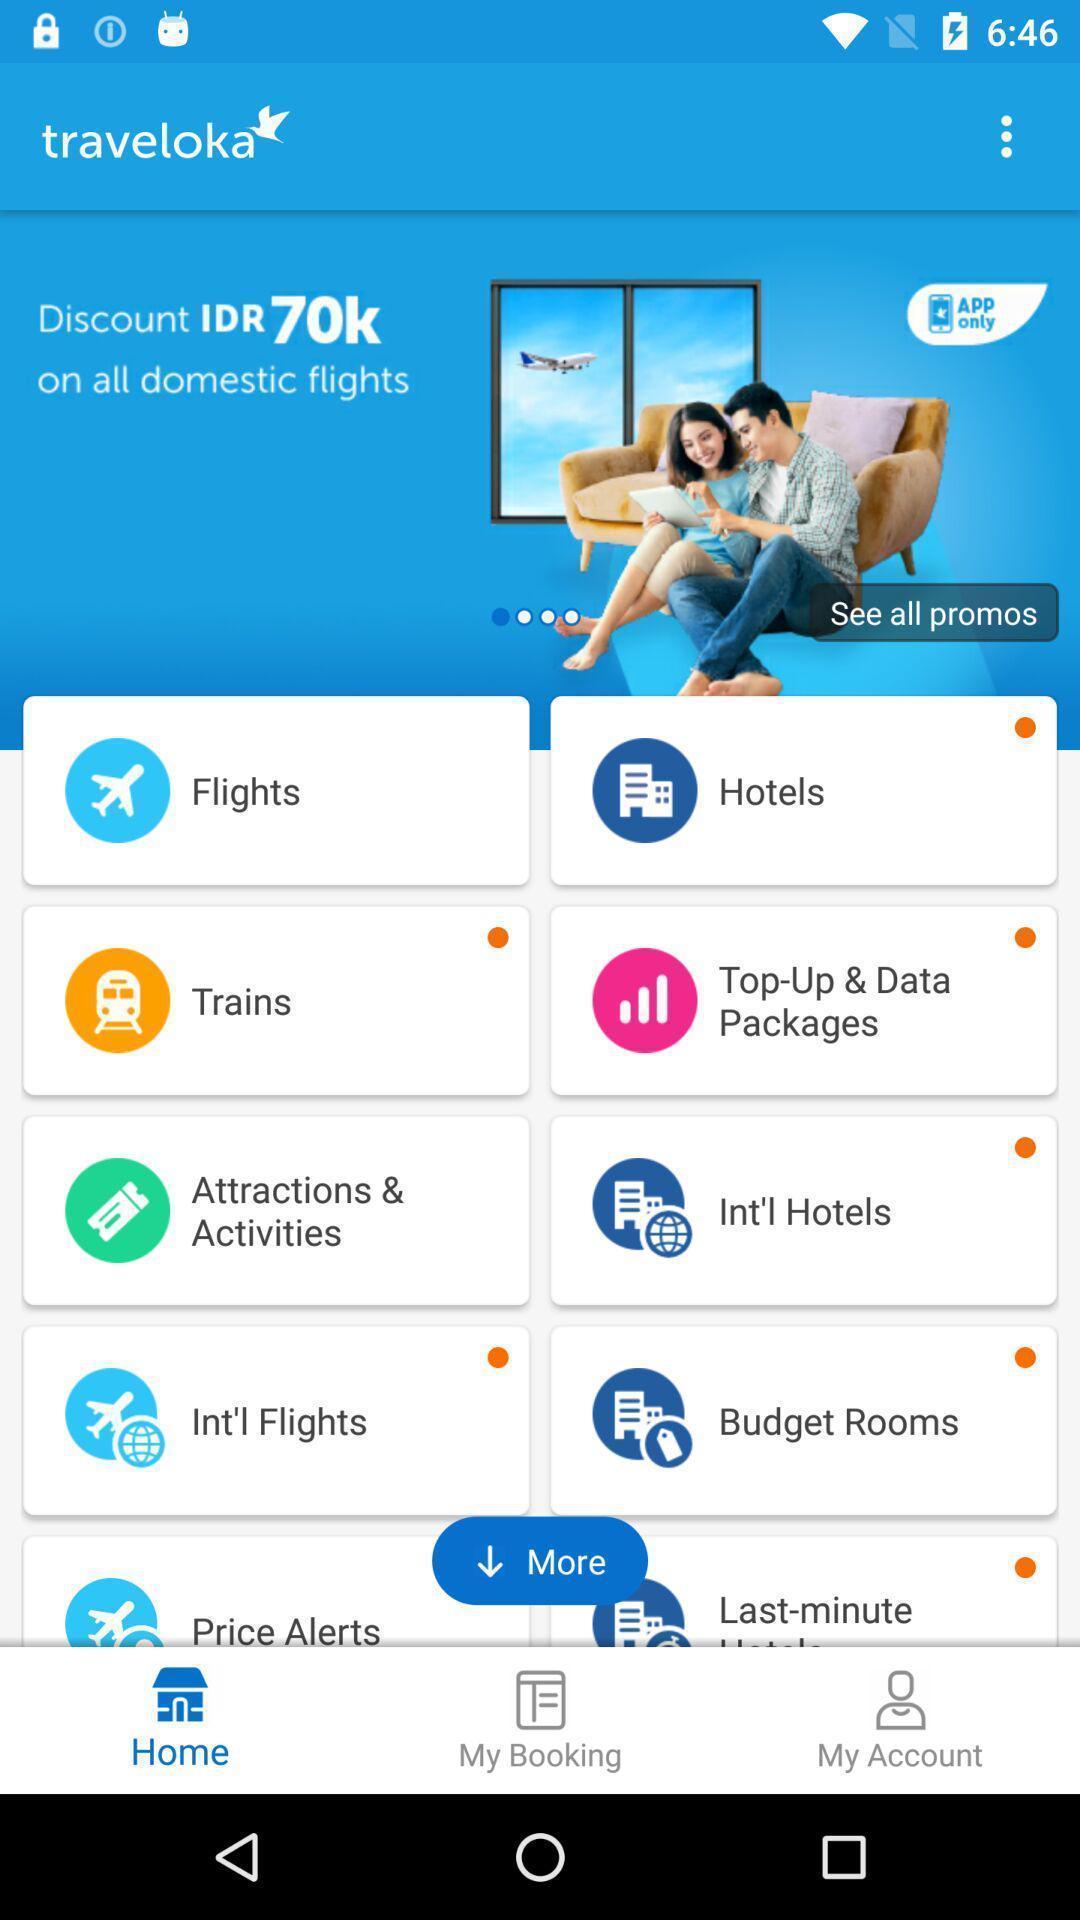Explain what's happening in this screen capture. Page showing about different categories in application. 